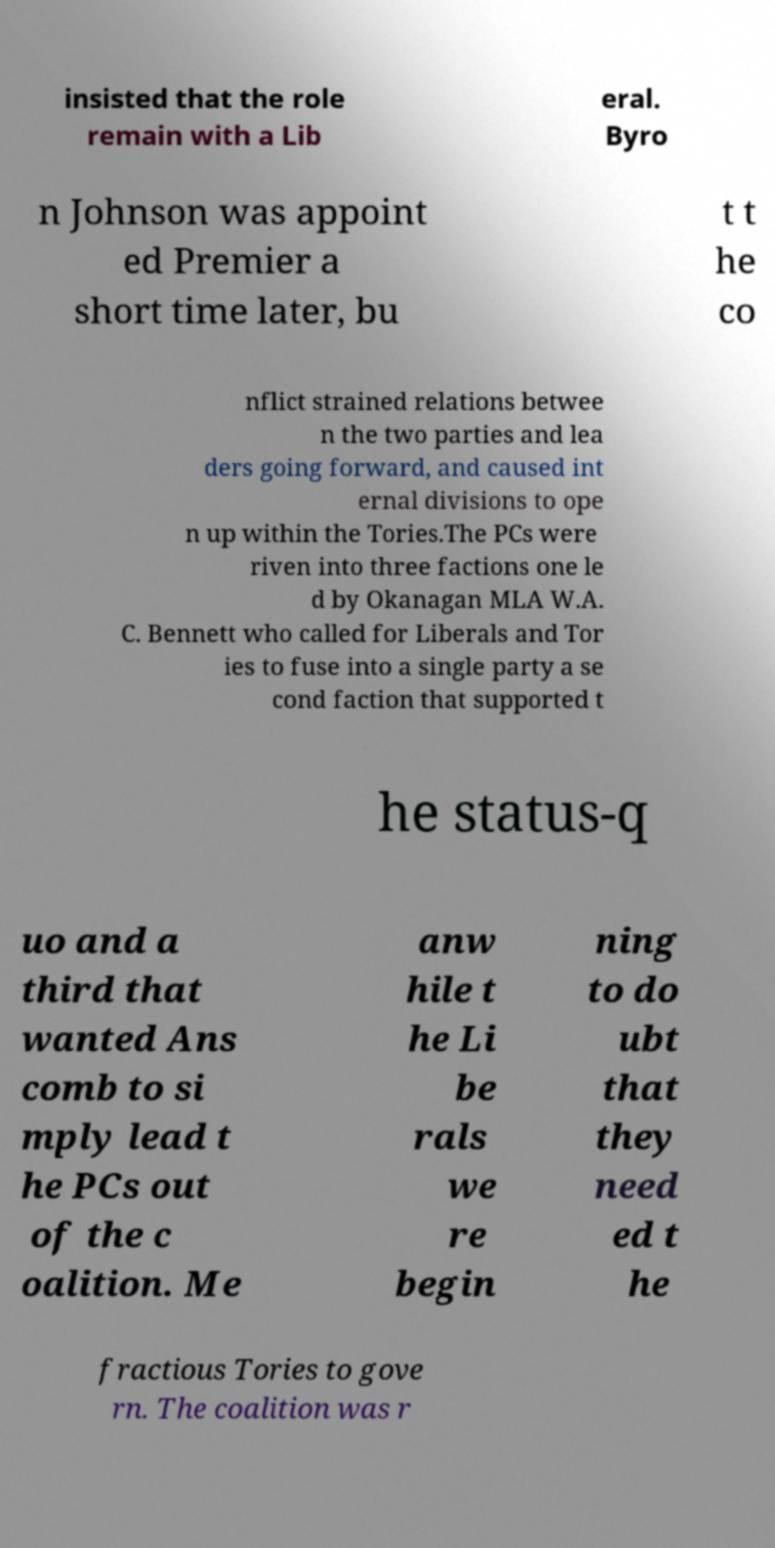What messages or text are displayed in this image? I need them in a readable, typed format. insisted that the role remain with a Lib eral. Byro n Johnson was appoint ed Premier a short time later, bu t t he co nflict strained relations betwee n the two parties and lea ders going forward, and caused int ernal divisions to ope n up within the Tories.The PCs were riven into three factions one le d by Okanagan MLA W.A. C. Bennett who called for Liberals and Tor ies to fuse into a single party a se cond faction that supported t he status-q uo and a third that wanted Ans comb to si mply lead t he PCs out of the c oalition. Me anw hile t he Li be rals we re begin ning to do ubt that they need ed t he fractious Tories to gove rn. The coalition was r 